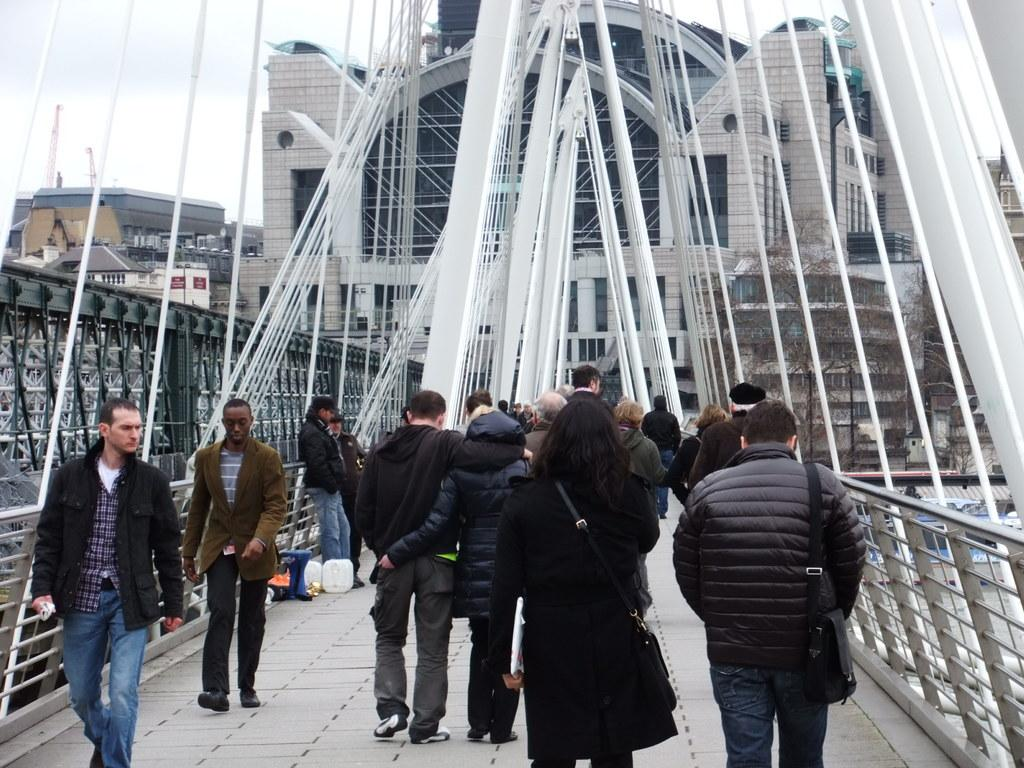What type of structures can be seen in the image? There are buildings in the image. What are the people in the image doing? Some people in the image are walking on a bridge, and some are carrying bags. What other tall structures can be seen in the image? There are towers visible in the image. How would you describe the weather in the image? The sky is cloudy in the image. Can you see any monkeys in the image? No, there are no monkeys present in the image. What type of food are the chickens eating in the image? There are no chickens present in the image, so it is not possible to determine what they might be eating. 